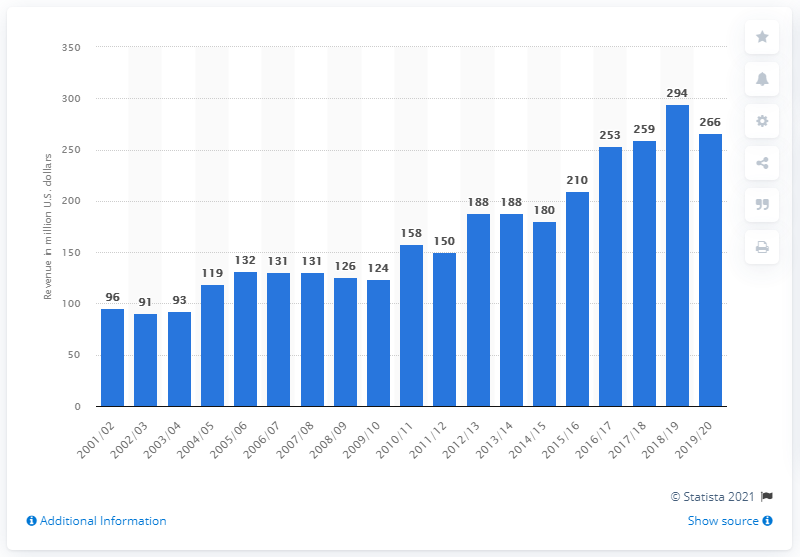Specify some key components in this picture. The Miami Heat's last season was in 2001/02. The estimated revenue of the Miami Heat in the 2019/2020 season was approximately 266 million dollars. During the 2019/2020 season, the Miami Heat's revenue reached its peak. 